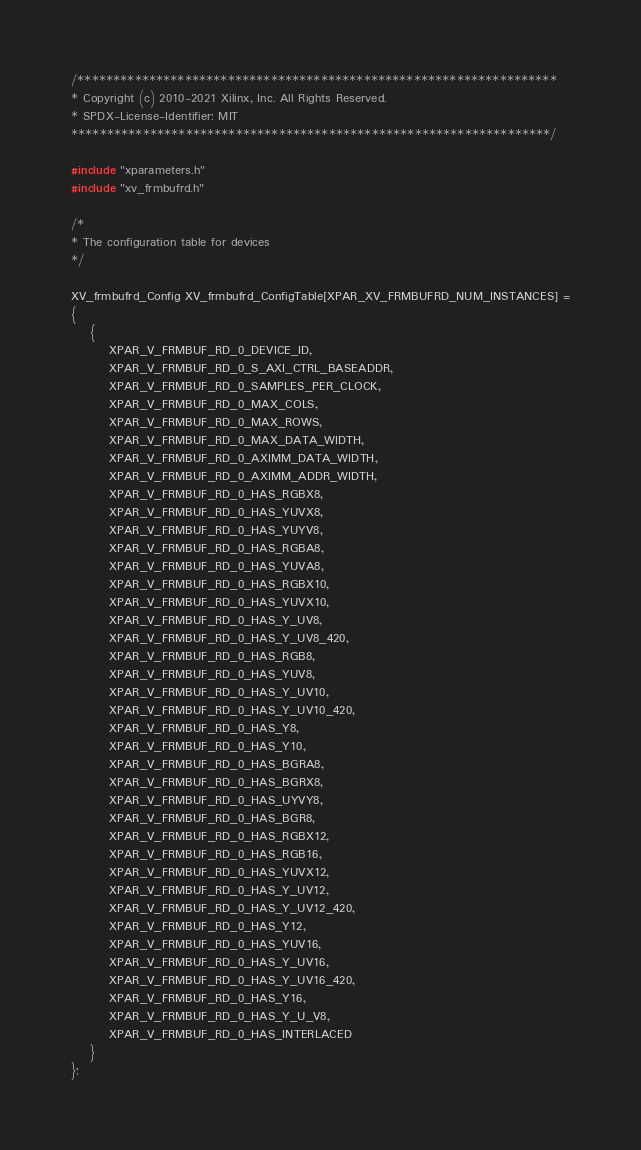Convert code to text. <code><loc_0><loc_0><loc_500><loc_500><_C_>
/*******************************************************************
* Copyright (c) 2010-2021 Xilinx, Inc. All Rights Reserved.
* SPDX-License-Identifier: MIT
*******************************************************************/

#include "xparameters.h"
#include "xv_frmbufrd.h"

/*
* The configuration table for devices
*/

XV_frmbufrd_Config XV_frmbufrd_ConfigTable[XPAR_XV_FRMBUFRD_NUM_INSTANCES] =
{
	{
		XPAR_V_FRMBUF_RD_0_DEVICE_ID,
		XPAR_V_FRMBUF_RD_0_S_AXI_CTRL_BASEADDR,
		XPAR_V_FRMBUF_RD_0_SAMPLES_PER_CLOCK,
		XPAR_V_FRMBUF_RD_0_MAX_COLS,
		XPAR_V_FRMBUF_RD_0_MAX_ROWS,
		XPAR_V_FRMBUF_RD_0_MAX_DATA_WIDTH,
		XPAR_V_FRMBUF_RD_0_AXIMM_DATA_WIDTH,
		XPAR_V_FRMBUF_RD_0_AXIMM_ADDR_WIDTH,
		XPAR_V_FRMBUF_RD_0_HAS_RGBX8,
		XPAR_V_FRMBUF_RD_0_HAS_YUVX8,
		XPAR_V_FRMBUF_RD_0_HAS_YUYV8,
		XPAR_V_FRMBUF_RD_0_HAS_RGBA8,
		XPAR_V_FRMBUF_RD_0_HAS_YUVA8,
		XPAR_V_FRMBUF_RD_0_HAS_RGBX10,
		XPAR_V_FRMBUF_RD_0_HAS_YUVX10,
		XPAR_V_FRMBUF_RD_0_HAS_Y_UV8,
		XPAR_V_FRMBUF_RD_0_HAS_Y_UV8_420,
		XPAR_V_FRMBUF_RD_0_HAS_RGB8,
		XPAR_V_FRMBUF_RD_0_HAS_YUV8,
		XPAR_V_FRMBUF_RD_0_HAS_Y_UV10,
		XPAR_V_FRMBUF_RD_0_HAS_Y_UV10_420,
		XPAR_V_FRMBUF_RD_0_HAS_Y8,
		XPAR_V_FRMBUF_RD_0_HAS_Y10,
		XPAR_V_FRMBUF_RD_0_HAS_BGRA8,
		XPAR_V_FRMBUF_RD_0_HAS_BGRX8,
		XPAR_V_FRMBUF_RD_0_HAS_UYVY8,
		XPAR_V_FRMBUF_RD_0_HAS_BGR8,
		XPAR_V_FRMBUF_RD_0_HAS_RGBX12,
		XPAR_V_FRMBUF_RD_0_HAS_RGB16,
		XPAR_V_FRMBUF_RD_0_HAS_YUVX12,
		XPAR_V_FRMBUF_RD_0_HAS_Y_UV12,
		XPAR_V_FRMBUF_RD_0_HAS_Y_UV12_420,
		XPAR_V_FRMBUF_RD_0_HAS_Y12,
		XPAR_V_FRMBUF_RD_0_HAS_YUV16,
		XPAR_V_FRMBUF_RD_0_HAS_Y_UV16,
		XPAR_V_FRMBUF_RD_0_HAS_Y_UV16_420,
		XPAR_V_FRMBUF_RD_0_HAS_Y16,
		XPAR_V_FRMBUF_RD_0_HAS_Y_U_V8,
		XPAR_V_FRMBUF_RD_0_HAS_INTERLACED
	}
};
</code> 